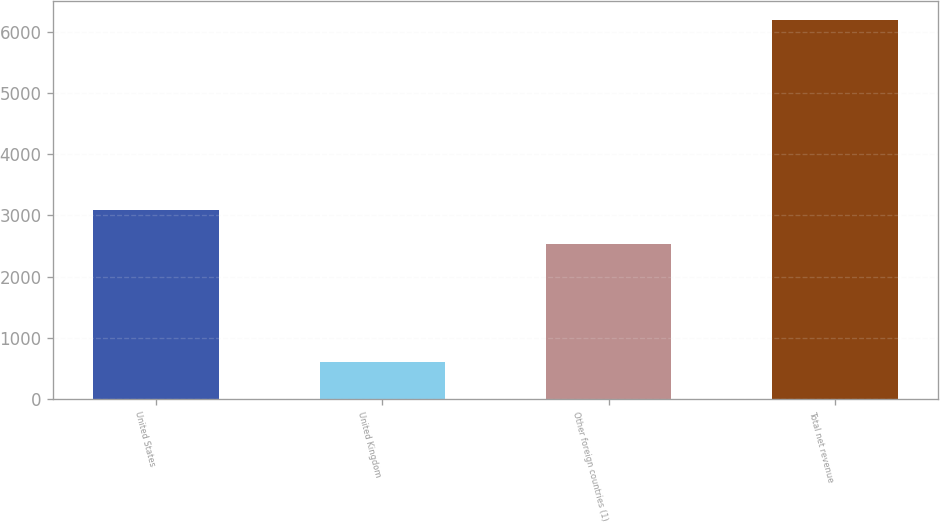<chart> <loc_0><loc_0><loc_500><loc_500><bar_chart><fcel>United States<fcel>United Kingdom<fcel>Other foreign countries (1)<fcel>Total net revenue<nl><fcel>3094.1<fcel>599<fcel>2535<fcel>6190<nl></chart> 